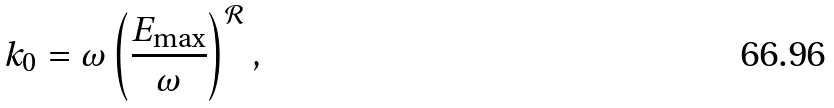<formula> <loc_0><loc_0><loc_500><loc_500>k _ { 0 } = \omega \left ( \frac { E _ { \max } } { \omega } \right ) ^ { \mathcal { R } } ,</formula> 